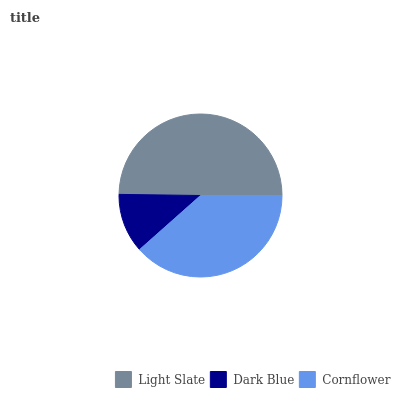Is Dark Blue the minimum?
Answer yes or no. Yes. Is Light Slate the maximum?
Answer yes or no. Yes. Is Cornflower the minimum?
Answer yes or no. No. Is Cornflower the maximum?
Answer yes or no. No. Is Cornflower greater than Dark Blue?
Answer yes or no. Yes. Is Dark Blue less than Cornflower?
Answer yes or no. Yes. Is Dark Blue greater than Cornflower?
Answer yes or no. No. Is Cornflower less than Dark Blue?
Answer yes or no. No. Is Cornflower the high median?
Answer yes or no. Yes. Is Cornflower the low median?
Answer yes or no. Yes. Is Dark Blue the high median?
Answer yes or no. No. Is Dark Blue the low median?
Answer yes or no. No. 